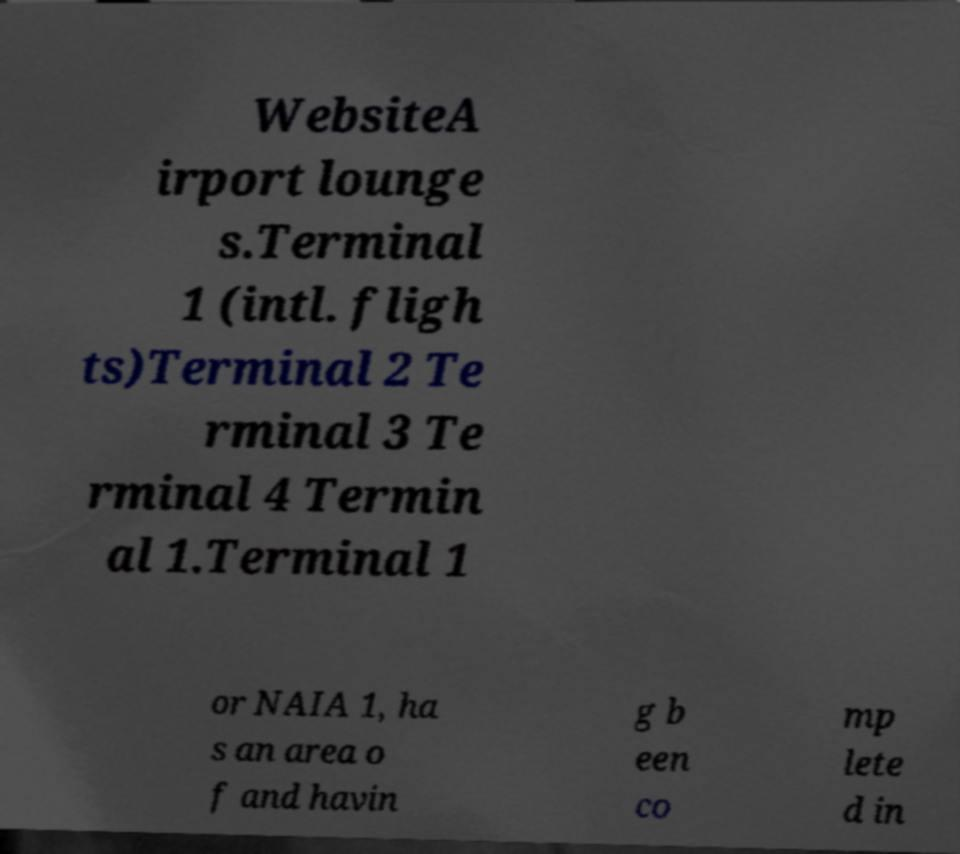Please read and relay the text visible in this image. What does it say? WebsiteA irport lounge s.Terminal 1 (intl. fligh ts)Terminal 2 Te rminal 3 Te rminal 4 Termin al 1.Terminal 1 or NAIA 1, ha s an area o f and havin g b een co mp lete d in 